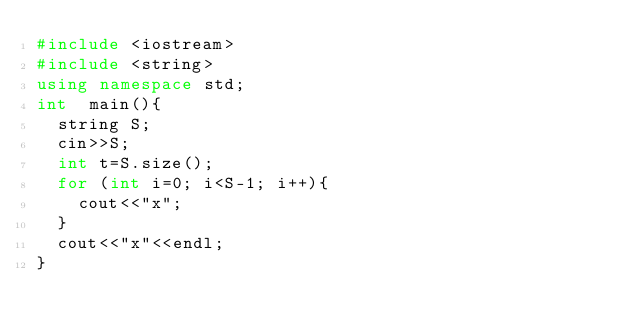Convert code to text. <code><loc_0><loc_0><loc_500><loc_500><_C++_>#include <iostream>
#include <string>
using namespace std;
int  main(){
  string S;
  cin>>S;
  int t=S.size();
  for (int i=0; i<S-1; i++){ 
    cout<<"x";
  }
  cout<<"x"<<endl;
}
  
  </code> 